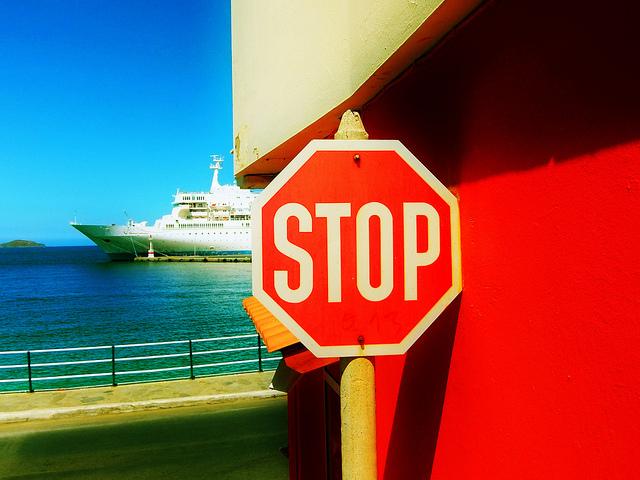Is the sun coming up or going down?
Concise answer only. Going down. What kind of material is the stop sign post made of?
Be succinct. Metal. Which is larger, the ship or the stop sign?
Answer briefly. Ship. How many stop signs is there?
Write a very short answer. 1. 